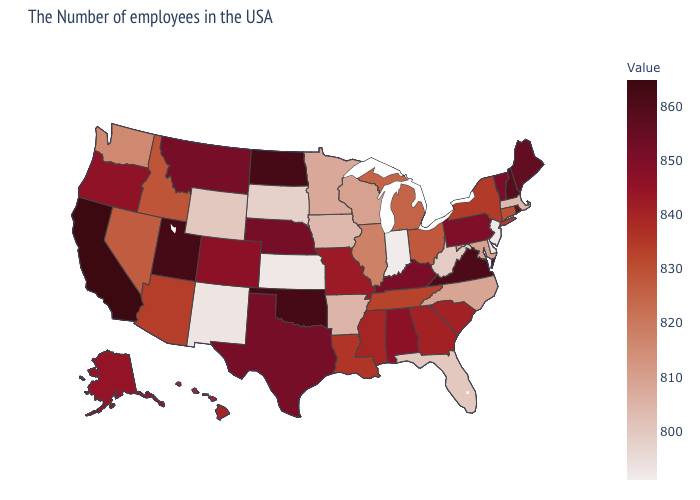Is the legend a continuous bar?
Be succinct. Yes. Among the states that border Iowa , does South Dakota have the lowest value?
Be succinct. Yes. Which states have the lowest value in the USA?
Concise answer only. Indiana. Does the map have missing data?
Quick response, please. No. Among the states that border North Dakota , does South Dakota have the highest value?
Quick response, please. No. 